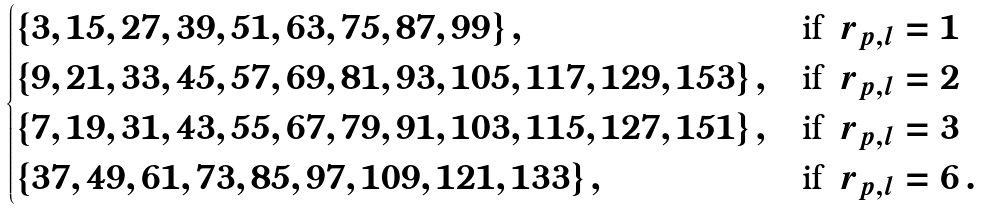<formula> <loc_0><loc_0><loc_500><loc_500>\begin{cases} \{ 3 , 1 5 , 2 7 , 3 9 , 5 1 , 6 3 , 7 5 , 8 7 , 9 9 \} \, , & \text {if } \, r _ { p , l } = 1 \\ \{ 9 , 2 1 , 3 3 , 4 5 , 5 7 , 6 9 , 8 1 , 9 3 , 1 0 5 , 1 1 7 , 1 2 9 , 1 5 3 \} \, , & \text {if } \, r _ { p , l } = 2 \\ \{ 7 , 1 9 , 3 1 , 4 3 , 5 5 , 6 7 , 7 9 , 9 1 , 1 0 3 , 1 1 5 , 1 2 7 , 1 5 1 \} \, , & \text {if } \, r _ { p , l } = 3 \\ \{ 3 7 , 4 9 , 6 1 , 7 3 , 8 5 , 9 7 , 1 0 9 , 1 2 1 , 1 3 3 \} \, , & \text {if } \, r _ { p , l } = 6 \, . \end{cases}</formula> 